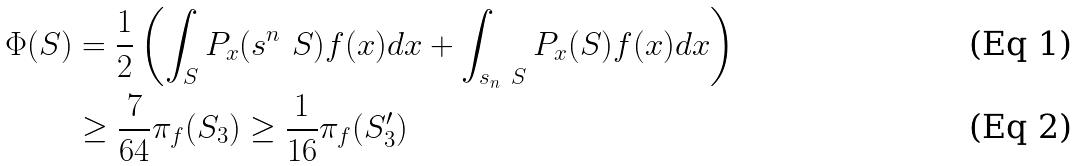<formula> <loc_0><loc_0><loc_500><loc_500>\Phi ( S ) & = \frac { 1 } { 2 } \left ( \int _ { S } P _ { x } ( \real s ^ { n } \ S ) f ( x ) d x + \int _ { \real s _ { n } \ S } P _ { x } ( S ) f ( x ) d x \right ) \\ & \geq \frac { 7 } { 6 4 } \pi _ { f } ( S _ { 3 } ) \geq \frac { 1 } { 1 6 } \pi _ { f } ( S _ { 3 } ^ { \prime } )</formula> 